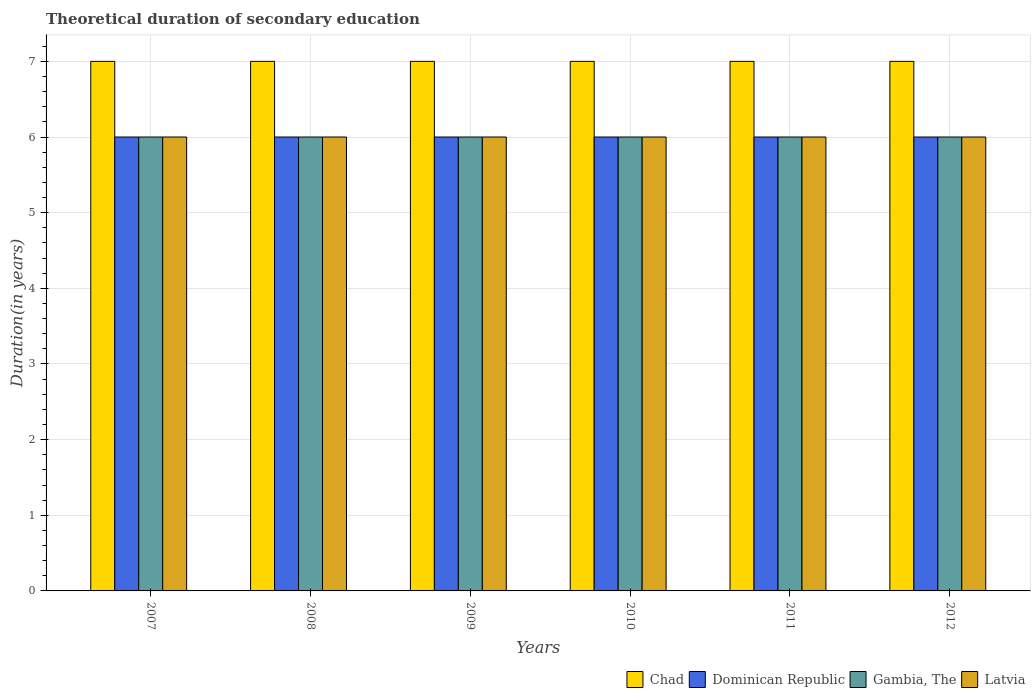How many different coloured bars are there?
Offer a very short reply. 4. Are the number of bars per tick equal to the number of legend labels?
Provide a short and direct response. Yes. How many bars are there on the 3rd tick from the left?
Your response must be concise. 4. How many bars are there on the 2nd tick from the right?
Keep it short and to the point. 4. What is the label of the 2nd group of bars from the left?
Keep it short and to the point. 2008. In how many cases, is the number of bars for a given year not equal to the number of legend labels?
Provide a succinct answer. 0. Across all years, what is the maximum total theoretical duration of secondary education in Latvia?
Your answer should be compact. 6. Across all years, what is the minimum total theoretical duration of secondary education in Chad?
Provide a succinct answer. 7. In which year was the total theoretical duration of secondary education in Chad maximum?
Give a very brief answer. 2007. What is the total total theoretical duration of secondary education in Dominican Republic in the graph?
Ensure brevity in your answer.  36. What is the difference between the total theoretical duration of secondary education in Chad in 2009 and that in 2010?
Give a very brief answer. 0. What is the difference between the total theoretical duration of secondary education in Latvia in 2010 and the total theoretical duration of secondary education in Chad in 2012?
Your answer should be very brief. -1. What is the average total theoretical duration of secondary education in Dominican Republic per year?
Ensure brevity in your answer.  6. In how many years, is the total theoretical duration of secondary education in Latvia greater than 3.6 years?
Provide a short and direct response. 6. What is the ratio of the total theoretical duration of secondary education in Dominican Republic in 2007 to that in 2011?
Keep it short and to the point. 1. Is the difference between the total theoretical duration of secondary education in Gambia, The in 2007 and 2010 greater than the difference between the total theoretical duration of secondary education in Latvia in 2007 and 2010?
Offer a very short reply. No. What is the difference between the highest and the second highest total theoretical duration of secondary education in Dominican Republic?
Provide a succinct answer. 0. What is the difference between the highest and the lowest total theoretical duration of secondary education in Gambia, The?
Your answer should be compact. 0. Is the sum of the total theoretical duration of secondary education in Chad in 2011 and 2012 greater than the maximum total theoretical duration of secondary education in Dominican Republic across all years?
Ensure brevity in your answer.  Yes. What does the 2nd bar from the left in 2008 represents?
Keep it short and to the point. Dominican Republic. What does the 1st bar from the right in 2010 represents?
Give a very brief answer. Latvia. Are all the bars in the graph horizontal?
Make the answer very short. No. What is the difference between two consecutive major ticks on the Y-axis?
Provide a short and direct response. 1. Are the values on the major ticks of Y-axis written in scientific E-notation?
Provide a short and direct response. No. Does the graph contain any zero values?
Make the answer very short. No. Does the graph contain grids?
Make the answer very short. Yes. Where does the legend appear in the graph?
Your response must be concise. Bottom right. How many legend labels are there?
Offer a very short reply. 4. How are the legend labels stacked?
Make the answer very short. Horizontal. What is the title of the graph?
Give a very brief answer. Theoretical duration of secondary education. Does "Comoros" appear as one of the legend labels in the graph?
Provide a short and direct response. No. What is the label or title of the Y-axis?
Offer a very short reply. Duration(in years). What is the Duration(in years) in Chad in 2007?
Your answer should be very brief. 7. What is the Duration(in years) of Latvia in 2007?
Make the answer very short. 6. What is the Duration(in years) of Latvia in 2008?
Your answer should be compact. 6. What is the Duration(in years) of Chad in 2009?
Your response must be concise. 7. What is the Duration(in years) in Dominican Republic in 2009?
Offer a very short reply. 6. What is the Duration(in years) of Dominican Republic in 2010?
Make the answer very short. 6. What is the Duration(in years) of Dominican Republic in 2011?
Keep it short and to the point. 6. What is the Duration(in years) of Latvia in 2011?
Give a very brief answer. 6. What is the Duration(in years) of Latvia in 2012?
Provide a succinct answer. 6. Across all years, what is the maximum Duration(in years) of Chad?
Provide a short and direct response. 7. Across all years, what is the maximum Duration(in years) of Dominican Republic?
Make the answer very short. 6. Across all years, what is the maximum Duration(in years) in Gambia, The?
Provide a short and direct response. 6. Across all years, what is the maximum Duration(in years) in Latvia?
Your response must be concise. 6. What is the total Duration(in years) in Chad in the graph?
Offer a very short reply. 42. What is the total Duration(in years) in Gambia, The in the graph?
Offer a terse response. 36. What is the difference between the Duration(in years) in Chad in 2007 and that in 2008?
Your answer should be compact. 0. What is the difference between the Duration(in years) of Chad in 2007 and that in 2009?
Keep it short and to the point. 0. What is the difference between the Duration(in years) of Dominican Republic in 2007 and that in 2009?
Keep it short and to the point. 0. What is the difference between the Duration(in years) in Gambia, The in 2007 and that in 2009?
Your answer should be compact. 0. What is the difference between the Duration(in years) of Chad in 2007 and that in 2010?
Offer a very short reply. 0. What is the difference between the Duration(in years) of Gambia, The in 2007 and that in 2010?
Make the answer very short. 0. What is the difference between the Duration(in years) in Latvia in 2007 and that in 2010?
Provide a short and direct response. 0. What is the difference between the Duration(in years) of Gambia, The in 2007 and that in 2011?
Ensure brevity in your answer.  0. What is the difference between the Duration(in years) in Latvia in 2007 and that in 2011?
Keep it short and to the point. 0. What is the difference between the Duration(in years) in Chad in 2007 and that in 2012?
Offer a very short reply. 0. What is the difference between the Duration(in years) in Gambia, The in 2007 and that in 2012?
Offer a very short reply. 0. What is the difference between the Duration(in years) in Chad in 2008 and that in 2009?
Provide a short and direct response. 0. What is the difference between the Duration(in years) in Gambia, The in 2008 and that in 2009?
Offer a terse response. 0. What is the difference between the Duration(in years) in Chad in 2008 and that in 2010?
Your answer should be very brief. 0. What is the difference between the Duration(in years) of Gambia, The in 2008 and that in 2010?
Make the answer very short. 0. What is the difference between the Duration(in years) in Latvia in 2008 and that in 2010?
Provide a succinct answer. 0. What is the difference between the Duration(in years) in Dominican Republic in 2008 and that in 2011?
Provide a short and direct response. 0. What is the difference between the Duration(in years) of Gambia, The in 2008 and that in 2011?
Your answer should be compact. 0. What is the difference between the Duration(in years) in Latvia in 2008 and that in 2011?
Your response must be concise. 0. What is the difference between the Duration(in years) of Chad in 2008 and that in 2012?
Give a very brief answer. 0. What is the difference between the Duration(in years) in Dominican Republic in 2008 and that in 2012?
Your answer should be compact. 0. What is the difference between the Duration(in years) of Chad in 2009 and that in 2010?
Your answer should be very brief. 0. What is the difference between the Duration(in years) in Dominican Republic in 2009 and that in 2010?
Offer a terse response. 0. What is the difference between the Duration(in years) in Latvia in 2009 and that in 2010?
Your answer should be very brief. 0. What is the difference between the Duration(in years) in Chad in 2009 and that in 2011?
Give a very brief answer. 0. What is the difference between the Duration(in years) in Gambia, The in 2009 and that in 2011?
Offer a very short reply. 0. What is the difference between the Duration(in years) in Chad in 2009 and that in 2012?
Offer a terse response. 0. What is the difference between the Duration(in years) of Dominican Republic in 2009 and that in 2012?
Provide a short and direct response. 0. What is the difference between the Duration(in years) in Gambia, The in 2009 and that in 2012?
Ensure brevity in your answer.  0. What is the difference between the Duration(in years) in Latvia in 2009 and that in 2012?
Offer a terse response. 0. What is the difference between the Duration(in years) of Chad in 2010 and that in 2011?
Give a very brief answer. 0. What is the difference between the Duration(in years) in Dominican Republic in 2010 and that in 2012?
Offer a very short reply. 0. What is the difference between the Duration(in years) of Gambia, The in 2010 and that in 2012?
Provide a succinct answer. 0. What is the difference between the Duration(in years) of Chad in 2007 and the Duration(in years) of Dominican Republic in 2008?
Offer a terse response. 1. What is the difference between the Duration(in years) of Dominican Republic in 2007 and the Duration(in years) of Latvia in 2008?
Ensure brevity in your answer.  0. What is the difference between the Duration(in years) in Gambia, The in 2007 and the Duration(in years) in Latvia in 2008?
Ensure brevity in your answer.  0. What is the difference between the Duration(in years) of Chad in 2007 and the Duration(in years) of Gambia, The in 2009?
Provide a succinct answer. 1. What is the difference between the Duration(in years) of Dominican Republic in 2007 and the Duration(in years) of Gambia, The in 2009?
Your response must be concise. 0. What is the difference between the Duration(in years) in Dominican Republic in 2007 and the Duration(in years) in Latvia in 2009?
Provide a succinct answer. 0. What is the difference between the Duration(in years) of Chad in 2007 and the Duration(in years) of Dominican Republic in 2010?
Ensure brevity in your answer.  1. What is the difference between the Duration(in years) in Dominican Republic in 2007 and the Duration(in years) in Latvia in 2010?
Give a very brief answer. 0. What is the difference between the Duration(in years) in Gambia, The in 2007 and the Duration(in years) in Latvia in 2010?
Keep it short and to the point. 0. What is the difference between the Duration(in years) in Dominican Republic in 2007 and the Duration(in years) in Gambia, The in 2011?
Keep it short and to the point. 0. What is the difference between the Duration(in years) in Gambia, The in 2007 and the Duration(in years) in Latvia in 2011?
Make the answer very short. 0. What is the difference between the Duration(in years) of Chad in 2007 and the Duration(in years) of Gambia, The in 2012?
Your response must be concise. 1. What is the difference between the Duration(in years) in Dominican Republic in 2008 and the Duration(in years) in Gambia, The in 2009?
Offer a terse response. 0. What is the difference between the Duration(in years) of Gambia, The in 2008 and the Duration(in years) of Latvia in 2009?
Your response must be concise. 0. What is the difference between the Duration(in years) of Chad in 2008 and the Duration(in years) of Dominican Republic in 2010?
Give a very brief answer. 1. What is the difference between the Duration(in years) in Chad in 2008 and the Duration(in years) in Latvia in 2010?
Make the answer very short. 1. What is the difference between the Duration(in years) in Chad in 2008 and the Duration(in years) in Dominican Republic in 2011?
Ensure brevity in your answer.  1. What is the difference between the Duration(in years) of Gambia, The in 2008 and the Duration(in years) of Latvia in 2011?
Provide a short and direct response. 0. What is the difference between the Duration(in years) of Chad in 2008 and the Duration(in years) of Dominican Republic in 2012?
Offer a terse response. 1. What is the difference between the Duration(in years) of Chad in 2008 and the Duration(in years) of Latvia in 2012?
Your response must be concise. 1. What is the difference between the Duration(in years) of Gambia, The in 2008 and the Duration(in years) of Latvia in 2012?
Your response must be concise. 0. What is the difference between the Duration(in years) of Dominican Republic in 2009 and the Duration(in years) of Gambia, The in 2010?
Keep it short and to the point. 0. What is the difference between the Duration(in years) of Dominican Republic in 2009 and the Duration(in years) of Latvia in 2010?
Keep it short and to the point. 0. What is the difference between the Duration(in years) in Gambia, The in 2009 and the Duration(in years) in Latvia in 2010?
Provide a short and direct response. 0. What is the difference between the Duration(in years) of Chad in 2009 and the Duration(in years) of Dominican Republic in 2011?
Offer a terse response. 1. What is the difference between the Duration(in years) of Chad in 2009 and the Duration(in years) of Gambia, The in 2011?
Your answer should be very brief. 1. What is the difference between the Duration(in years) in Dominican Republic in 2009 and the Duration(in years) in Gambia, The in 2011?
Give a very brief answer. 0. What is the difference between the Duration(in years) of Gambia, The in 2009 and the Duration(in years) of Latvia in 2011?
Keep it short and to the point. 0. What is the difference between the Duration(in years) in Chad in 2009 and the Duration(in years) in Dominican Republic in 2012?
Offer a terse response. 1. What is the difference between the Duration(in years) in Chad in 2009 and the Duration(in years) in Latvia in 2012?
Give a very brief answer. 1. What is the difference between the Duration(in years) in Dominican Republic in 2009 and the Duration(in years) in Gambia, The in 2012?
Keep it short and to the point. 0. What is the difference between the Duration(in years) of Chad in 2010 and the Duration(in years) of Latvia in 2011?
Provide a succinct answer. 1. What is the difference between the Duration(in years) of Gambia, The in 2010 and the Duration(in years) of Latvia in 2011?
Offer a very short reply. 0. What is the difference between the Duration(in years) in Dominican Republic in 2010 and the Duration(in years) in Gambia, The in 2012?
Ensure brevity in your answer.  0. What is the difference between the Duration(in years) of Gambia, The in 2010 and the Duration(in years) of Latvia in 2012?
Your response must be concise. 0. What is the difference between the Duration(in years) of Chad in 2011 and the Duration(in years) of Dominican Republic in 2012?
Your response must be concise. 1. What is the difference between the Duration(in years) in Chad in 2011 and the Duration(in years) in Latvia in 2012?
Offer a very short reply. 1. What is the difference between the Duration(in years) in Dominican Republic in 2011 and the Duration(in years) in Gambia, The in 2012?
Provide a short and direct response. 0. What is the difference between the Duration(in years) in Dominican Republic in 2011 and the Duration(in years) in Latvia in 2012?
Offer a terse response. 0. What is the average Duration(in years) of Gambia, The per year?
Your response must be concise. 6. In the year 2007, what is the difference between the Duration(in years) in Chad and Duration(in years) in Gambia, The?
Offer a very short reply. 1. In the year 2007, what is the difference between the Duration(in years) of Dominican Republic and Duration(in years) of Gambia, The?
Give a very brief answer. 0. In the year 2008, what is the difference between the Duration(in years) of Chad and Duration(in years) of Dominican Republic?
Your response must be concise. 1. In the year 2008, what is the difference between the Duration(in years) in Chad and Duration(in years) in Latvia?
Ensure brevity in your answer.  1. In the year 2008, what is the difference between the Duration(in years) of Dominican Republic and Duration(in years) of Latvia?
Your response must be concise. 0. In the year 2009, what is the difference between the Duration(in years) of Chad and Duration(in years) of Dominican Republic?
Offer a terse response. 1. In the year 2009, what is the difference between the Duration(in years) in Dominican Republic and Duration(in years) in Latvia?
Your answer should be compact. 0. In the year 2009, what is the difference between the Duration(in years) in Gambia, The and Duration(in years) in Latvia?
Your answer should be compact. 0. In the year 2010, what is the difference between the Duration(in years) of Chad and Duration(in years) of Gambia, The?
Your answer should be very brief. 1. In the year 2010, what is the difference between the Duration(in years) of Gambia, The and Duration(in years) of Latvia?
Make the answer very short. 0. In the year 2011, what is the difference between the Duration(in years) of Chad and Duration(in years) of Dominican Republic?
Give a very brief answer. 1. In the year 2011, what is the difference between the Duration(in years) of Chad and Duration(in years) of Latvia?
Ensure brevity in your answer.  1. In the year 2011, what is the difference between the Duration(in years) of Dominican Republic and Duration(in years) of Latvia?
Your response must be concise. 0. In the year 2011, what is the difference between the Duration(in years) of Gambia, The and Duration(in years) of Latvia?
Offer a terse response. 0. In the year 2012, what is the difference between the Duration(in years) in Dominican Republic and Duration(in years) in Gambia, The?
Your response must be concise. 0. In the year 2012, what is the difference between the Duration(in years) in Dominican Republic and Duration(in years) in Latvia?
Offer a very short reply. 0. What is the ratio of the Duration(in years) of Dominican Republic in 2007 to that in 2008?
Your answer should be compact. 1. What is the ratio of the Duration(in years) of Dominican Republic in 2007 to that in 2009?
Your answer should be compact. 1. What is the ratio of the Duration(in years) of Gambia, The in 2007 to that in 2009?
Your response must be concise. 1. What is the ratio of the Duration(in years) of Dominican Republic in 2007 to that in 2010?
Offer a terse response. 1. What is the ratio of the Duration(in years) of Gambia, The in 2007 to that in 2010?
Ensure brevity in your answer.  1. What is the ratio of the Duration(in years) in Latvia in 2007 to that in 2010?
Offer a very short reply. 1. What is the ratio of the Duration(in years) of Chad in 2007 to that in 2011?
Provide a short and direct response. 1. What is the ratio of the Duration(in years) of Dominican Republic in 2007 to that in 2011?
Offer a very short reply. 1. What is the ratio of the Duration(in years) of Gambia, The in 2007 to that in 2011?
Make the answer very short. 1. What is the ratio of the Duration(in years) of Dominican Republic in 2007 to that in 2012?
Make the answer very short. 1. What is the ratio of the Duration(in years) of Latvia in 2007 to that in 2012?
Your response must be concise. 1. What is the ratio of the Duration(in years) in Chad in 2008 to that in 2009?
Your answer should be very brief. 1. What is the ratio of the Duration(in years) in Dominican Republic in 2008 to that in 2009?
Offer a terse response. 1. What is the ratio of the Duration(in years) of Gambia, The in 2008 to that in 2010?
Give a very brief answer. 1. What is the ratio of the Duration(in years) of Chad in 2008 to that in 2011?
Provide a short and direct response. 1. What is the ratio of the Duration(in years) of Dominican Republic in 2008 to that in 2011?
Give a very brief answer. 1. What is the ratio of the Duration(in years) in Latvia in 2008 to that in 2011?
Your answer should be compact. 1. What is the ratio of the Duration(in years) of Chad in 2008 to that in 2012?
Give a very brief answer. 1. What is the ratio of the Duration(in years) in Dominican Republic in 2008 to that in 2012?
Offer a terse response. 1. What is the ratio of the Duration(in years) of Latvia in 2008 to that in 2012?
Your answer should be compact. 1. What is the ratio of the Duration(in years) in Dominican Republic in 2009 to that in 2010?
Make the answer very short. 1. What is the ratio of the Duration(in years) in Latvia in 2009 to that in 2010?
Your response must be concise. 1. What is the ratio of the Duration(in years) in Chad in 2009 to that in 2011?
Make the answer very short. 1. What is the ratio of the Duration(in years) in Dominican Republic in 2009 to that in 2011?
Offer a very short reply. 1. What is the ratio of the Duration(in years) of Gambia, The in 2009 to that in 2012?
Your answer should be very brief. 1. What is the ratio of the Duration(in years) of Latvia in 2009 to that in 2012?
Offer a terse response. 1. What is the ratio of the Duration(in years) of Gambia, The in 2010 to that in 2011?
Make the answer very short. 1. What is the ratio of the Duration(in years) of Latvia in 2010 to that in 2011?
Provide a short and direct response. 1. What is the ratio of the Duration(in years) in Chad in 2010 to that in 2012?
Your answer should be very brief. 1. What is the ratio of the Duration(in years) of Dominican Republic in 2010 to that in 2012?
Offer a terse response. 1. What is the ratio of the Duration(in years) in Gambia, The in 2010 to that in 2012?
Your answer should be compact. 1. What is the ratio of the Duration(in years) of Latvia in 2010 to that in 2012?
Ensure brevity in your answer.  1. What is the ratio of the Duration(in years) in Chad in 2011 to that in 2012?
Offer a terse response. 1. What is the ratio of the Duration(in years) of Dominican Republic in 2011 to that in 2012?
Provide a short and direct response. 1. What is the ratio of the Duration(in years) in Gambia, The in 2011 to that in 2012?
Make the answer very short. 1. What is the ratio of the Duration(in years) in Latvia in 2011 to that in 2012?
Provide a succinct answer. 1. What is the difference between the highest and the second highest Duration(in years) of Chad?
Provide a succinct answer. 0. What is the difference between the highest and the second highest Duration(in years) in Gambia, The?
Offer a very short reply. 0. What is the difference between the highest and the second highest Duration(in years) of Latvia?
Give a very brief answer. 0. What is the difference between the highest and the lowest Duration(in years) of Gambia, The?
Your answer should be compact. 0. What is the difference between the highest and the lowest Duration(in years) of Latvia?
Make the answer very short. 0. 